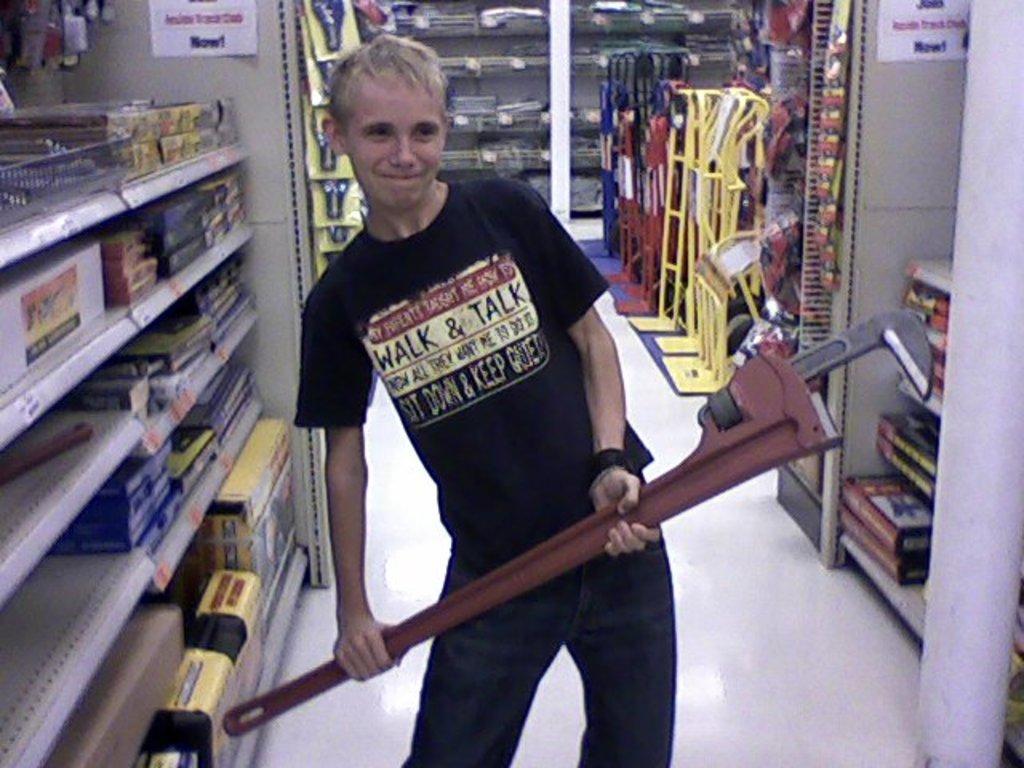Can you describe this image briefly? In this image, we can see a person standing and holding an object, we can see racks and there are some objects kept in the racks. 